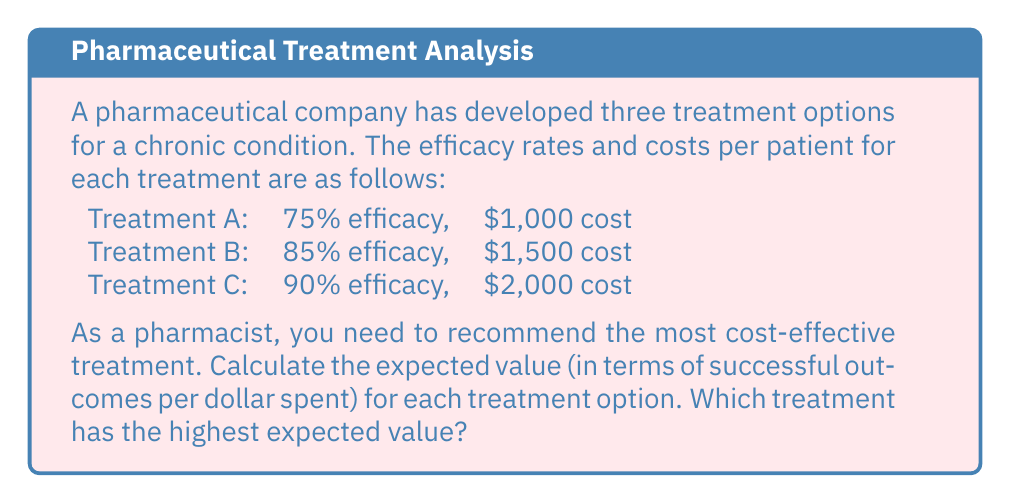Can you solve this math problem? To solve this problem, we need to calculate the expected value for each treatment option. The expected value in this context is the ratio of the efficacy rate to the cost, which gives us the success rate per dollar spent.

Let's calculate the expected value for each treatment:

1. Treatment A:
   $$ EV_A = \frac{\text{Efficacy}}{\text{Cost}} = \frac{0.75}{1000} = 0.00075 $$

2. Treatment B:
   $$ EV_B = \frac{\text{Efficacy}}{\text{Cost}} = \frac{0.85}{1500} \approx 0.000567 $$

3. Treatment C:
   $$ EV_C = \frac{\text{Efficacy}}{\text{Cost}} = \frac{0.90}{2000} = 0.00045 $$

To compare these values, we can multiply them by 1,000,000 to get the number of successful outcomes per million dollars spent:

Treatment A: $0.00075 \times 1,000,000 = 750$ successful outcomes per million dollars
Treatment B: $0.000567 \times 1,000,000 \approx 567$ successful outcomes per million dollars
Treatment C: $0.00045 \times 1,000,000 = 450$ successful outcomes per million dollars

Based on these calculations, Treatment A has the highest expected value, providing the most successful outcomes per dollar spent.
Answer: Treatment A has the highest expected value at 0.00075 successful outcomes per dollar spent, or 750 successful outcomes per million dollars spent. 